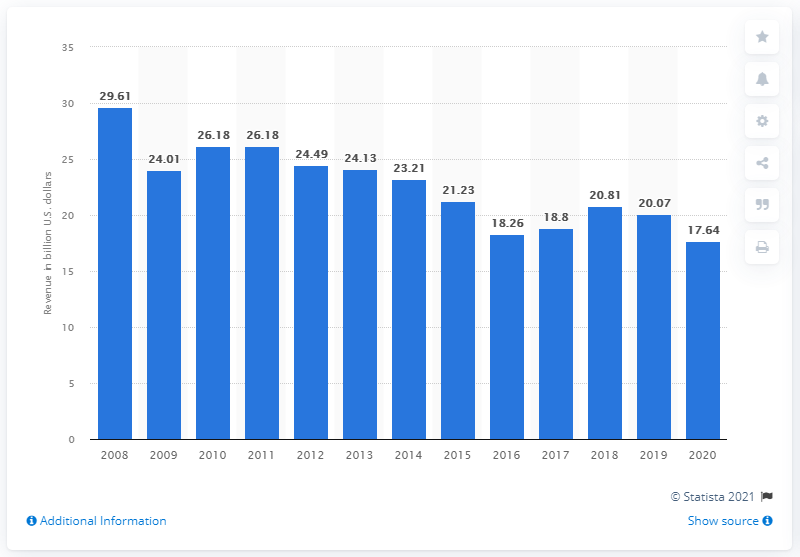Point out several critical features in this image. HP's revenue from printers and copiers in the fiscal year 2020 was 17.64 billion dollars. 